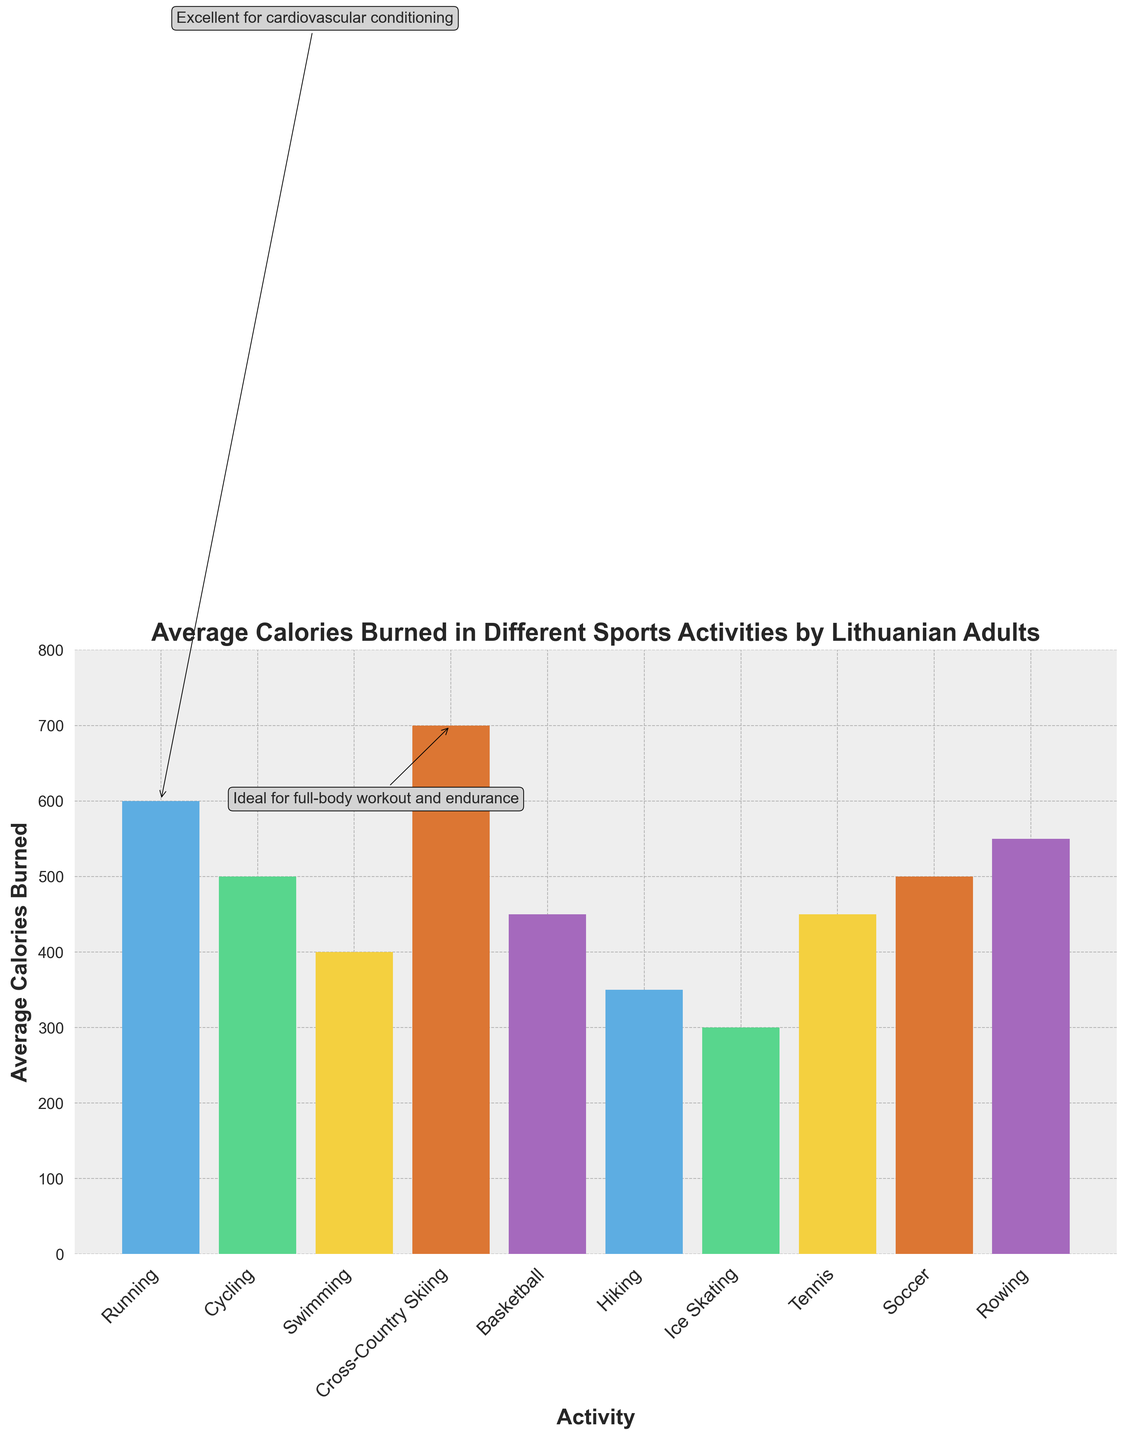What's the average number of calories burned among the activities listed? To find the average, sum all the average calories burned and divide by the number of activities: (600 + 500 + 400 + 700 + 450 + 350 + 300 + 450 + 500 + 550) / 10 = 4800 / 10 = 480
Answer: 480 Which activity burns the most calories on average, and how many calories does it burn? From the chart, Cross-Country Skiing has the highest bar at 700 average calories burned.
Answer: Cross-Country Skiing, 700 Is the average calories burned for running greater than swimming? By how much? Running burns 600 calories on average, while swimming burns 400. The difference is 600 - 400 = 200 calories.
Answer: Yes, by 200 calories Which activities are recommended for cardiovascular conditioning based on the annotations? The annotations indicate that Running is excellent for cardiovascular conditioning.
Answer: Running How many activities have a seasonal variation of "Spring to Fall"? List them. By examining the seasonal variation labels, the activities with "Spring to Fall" are Cycling, Hiking, Tennis, Soccer, and Rowing. Therefore, there are 5 such activities.
Answer: 5, Cycling, Hiking, Tennis, Soccer, Rowing Which season has the highest number of distinct activities, and what are they? The seasons and their corresponding activities are: Year-Round (Running, Basketball), Spring to Fall (Cycling, Hiking, Tennis, Soccer, Rowing), Summer (Swimming), Winter (Cross-Country Skiing, Ice Skating). Spring to Fall has the highest number, with 5 activities.
Answer: Spring to Fall, Cycling, Hiking, Tennis, Soccer, Rowing Comparing the average calories burned, which is higher: the combination of running and cycling or cross-country skiing and rowing? Running and Cycling burn 600 + 500 = 1100 calories combined. Cross-Country Skiing and Rowing burn 700 + 550 = 1250 calories combined. Cross-Country Skiing and Rowing are higher.
Answer: Cross-Country Skiing and Rowing What visual clue indicates that cross-country skiing is the activity burning the most calories? The bar corresponding to Cross-Country Skiing is the tallest in the chart and reaches 700 calories.
Answer: Tallest bar Which recommended conditioning activity is ideal for a full-body workout based on the annotations? The annotation boxes state that Cross-Country Skiing is ideal for a full-body workout and endurance.
Answer: Cross-Country Skiing How do the bars for activities recommended for leg strength compare visually? Cycling and Soccer are both great for leg strength, and their bars are similar in height, each around 500 calories.
Answer: Similar height (around 500) 